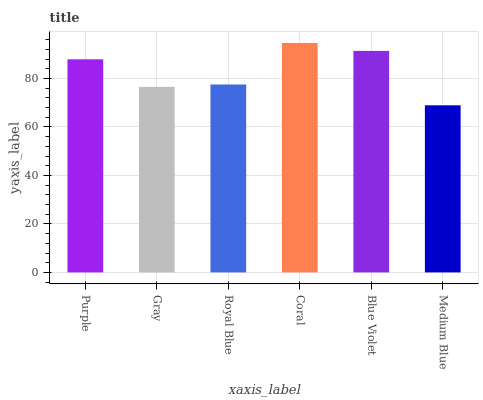Is Medium Blue the minimum?
Answer yes or no. Yes. Is Coral the maximum?
Answer yes or no. Yes. Is Gray the minimum?
Answer yes or no. No. Is Gray the maximum?
Answer yes or no. No. Is Purple greater than Gray?
Answer yes or no. Yes. Is Gray less than Purple?
Answer yes or no. Yes. Is Gray greater than Purple?
Answer yes or no. No. Is Purple less than Gray?
Answer yes or no. No. Is Purple the high median?
Answer yes or no. Yes. Is Royal Blue the low median?
Answer yes or no. Yes. Is Coral the high median?
Answer yes or no. No. Is Coral the low median?
Answer yes or no. No. 